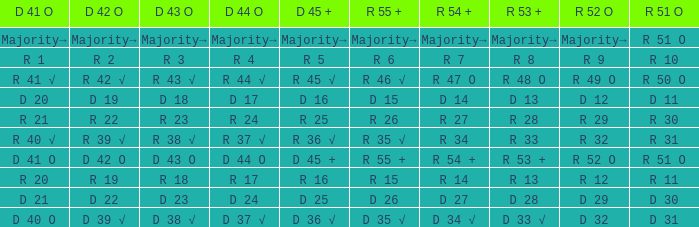What is the value of D 43 O that has a corresponding R 53 + value of r 8? R 3. 